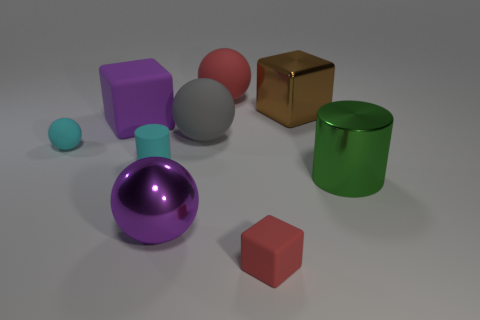Subtract all rubber blocks. How many blocks are left? 1 Subtract all gray spheres. How many spheres are left? 3 Add 1 green metallic spheres. How many objects exist? 10 Subtract 1 blocks. How many blocks are left? 2 Subtract all green balls. Subtract all red cylinders. How many balls are left? 4 Subtract all cylinders. How many objects are left? 7 Subtract all big shiny cylinders. Subtract all large rubber cubes. How many objects are left? 7 Add 4 tiny cyan spheres. How many tiny cyan spheres are left? 5 Add 1 brown shiny objects. How many brown shiny objects exist? 2 Subtract 0 gray cubes. How many objects are left? 9 